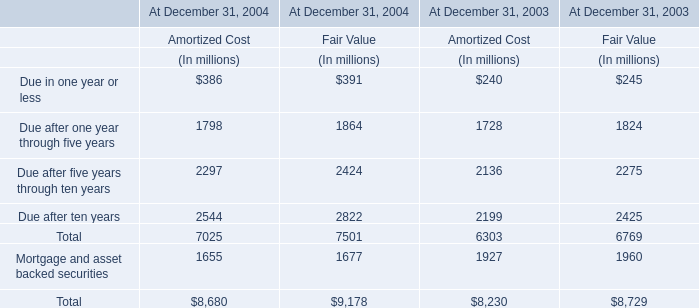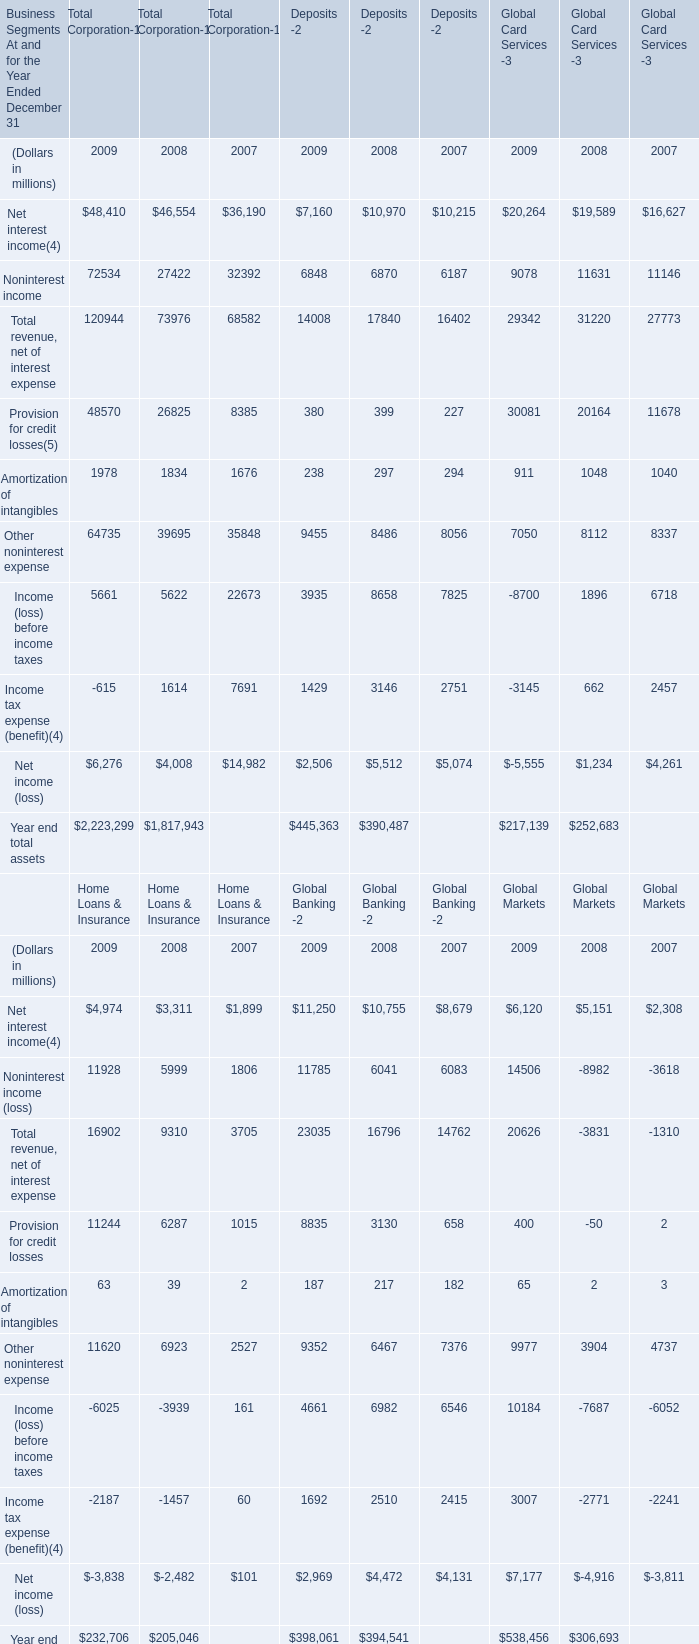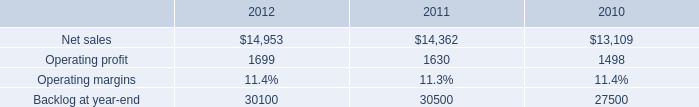what was the percent of the growth in the sales from 2011 to 2012 
Computations: ((14953 - 14362) / 14362)
Answer: 0.04115. How many Net interest income exceed the average of Net interest income in 2009? 
Answer: 2. 